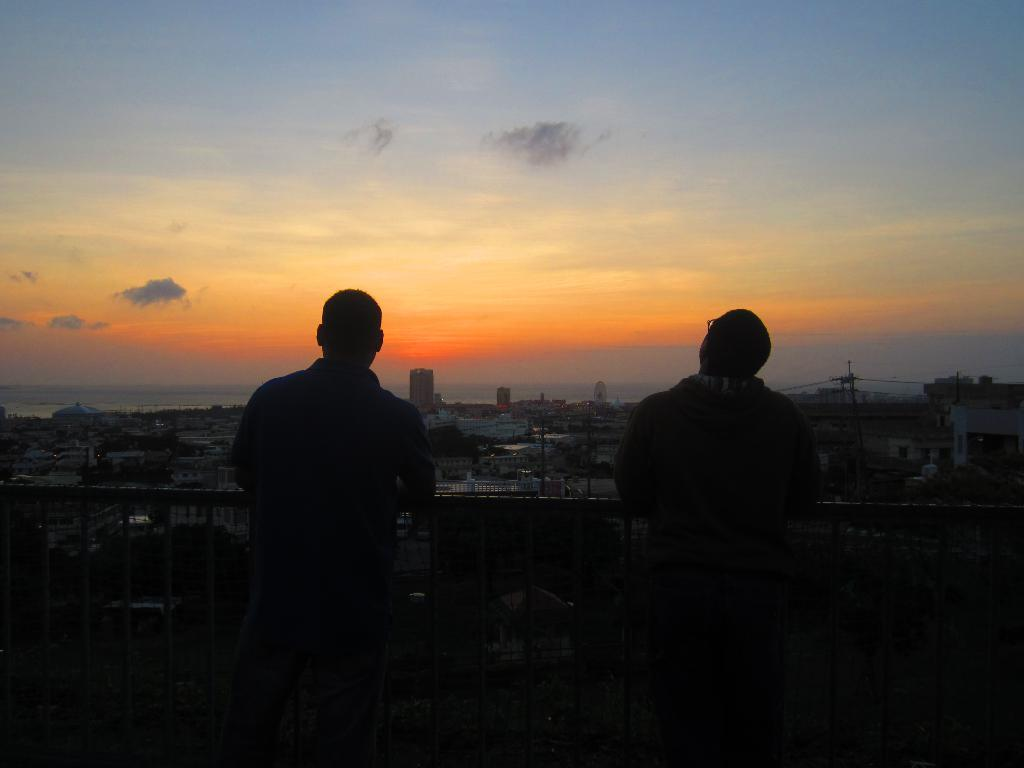How many people are in the image? There are people in the image, but the exact number is not specified. What are the people standing in front of? The people are standing in front of metal rods. What can be seen in the background of the image? In the background of the image, there are buildings, trees, poles, and clouds. What type of juice is being served at the board meeting in the image? There is no board meeting or juice present in the image. 